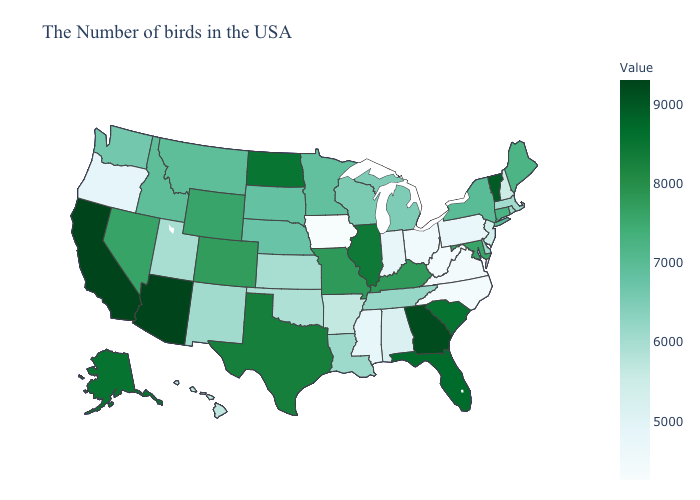Which states have the lowest value in the USA?
Concise answer only. Iowa. Does Montana have a higher value than Missouri?
Keep it brief. No. Does Mississippi have the lowest value in the USA?
Answer briefly. No. Which states hav the highest value in the Northeast?
Write a very short answer. Vermont. Does Arizona have the highest value in the USA?
Answer briefly. Yes. Does Texas have a higher value than Vermont?
Short answer required. No. Which states have the lowest value in the South?
Be succinct. West Virginia. Which states have the highest value in the USA?
Quick response, please. Arizona. Which states hav the highest value in the Northeast?
Answer briefly. Vermont. 